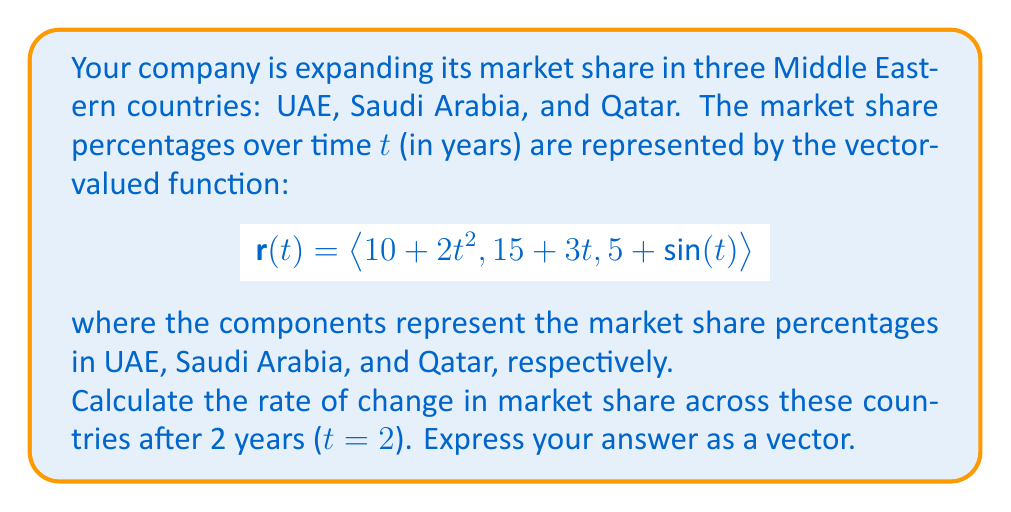Could you help me with this problem? To find the rate of change in market share across the countries, we need to calculate the derivative of the vector-valued function $\mathbf{r}(t)$ and evaluate it at t = 2.

Step 1: Calculate the derivative of $\mathbf{r}(t)$
$$\frac{d}{dt}\mathbf{r}(t) = \langle \frac{d}{dt}(10 + 2t^2), \frac{d}{dt}(15 + 3t), \frac{d}{dt}(5 + \sin(t)) \rangle$$

Step 2: Simplify the derivatives
$$\frac{d}{dt}\mathbf{r}(t) = \langle 4t, 3, \cos(t) \rangle$$

Step 3: Evaluate the derivative at t = 2
$$\frac{d}{dt}\mathbf{r}(2) = \langle 4(2), 3, \cos(2) \rangle$$

Step 4: Simplify
$$\frac{d}{dt}\mathbf{r}(2) = \langle 8, 3, \cos(2) \rangle$$

Step 5: Calculate $\cos(2)$ (approximately -0.4161)
$$\frac{d}{dt}\mathbf{r}(2) \approx \langle 8, 3, -0.4161 \rangle$$

This vector represents the rate of change in market share percentages per year for UAE, Saudi Arabia, and Qatar, respectively, after 2 years.
Answer: $\langle 8, 3, -0.4161 \rangle$ percent/year 